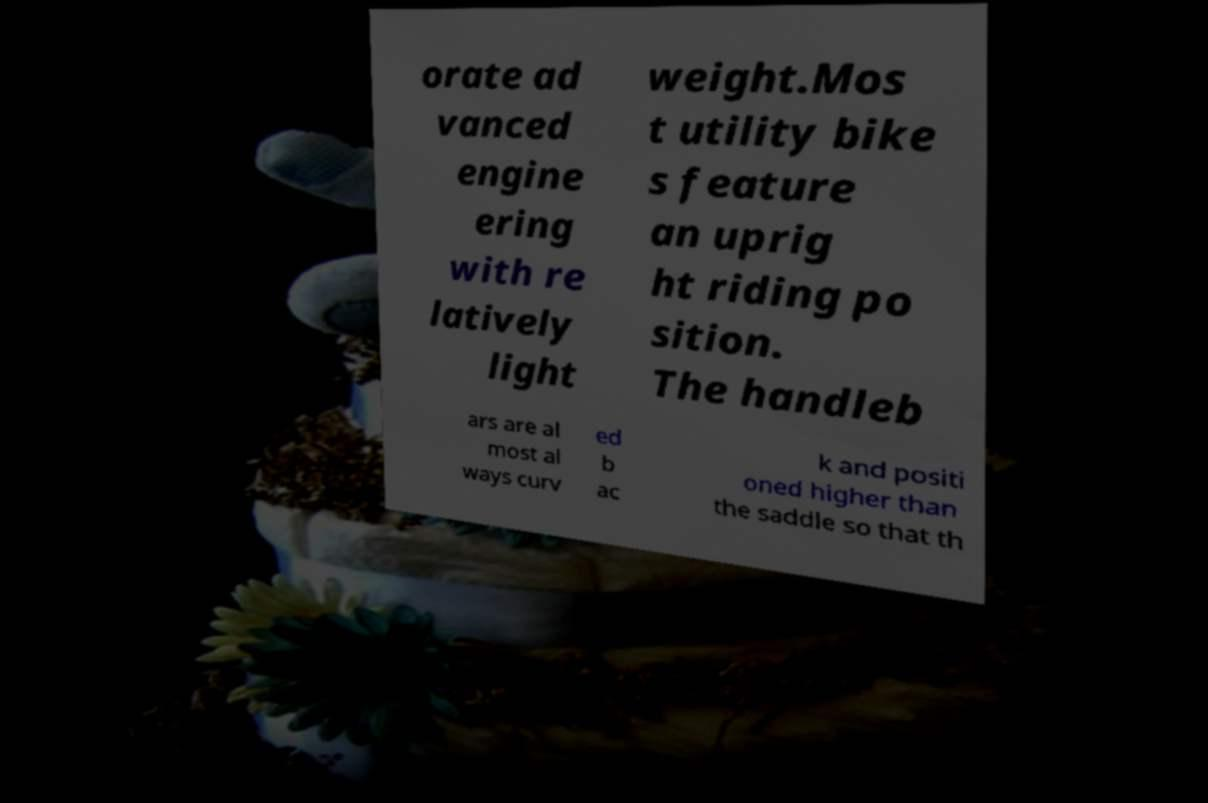There's text embedded in this image that I need extracted. Can you transcribe it verbatim? orate ad vanced engine ering with re latively light weight.Mos t utility bike s feature an uprig ht riding po sition. The handleb ars are al most al ways curv ed b ac k and positi oned higher than the saddle so that th 